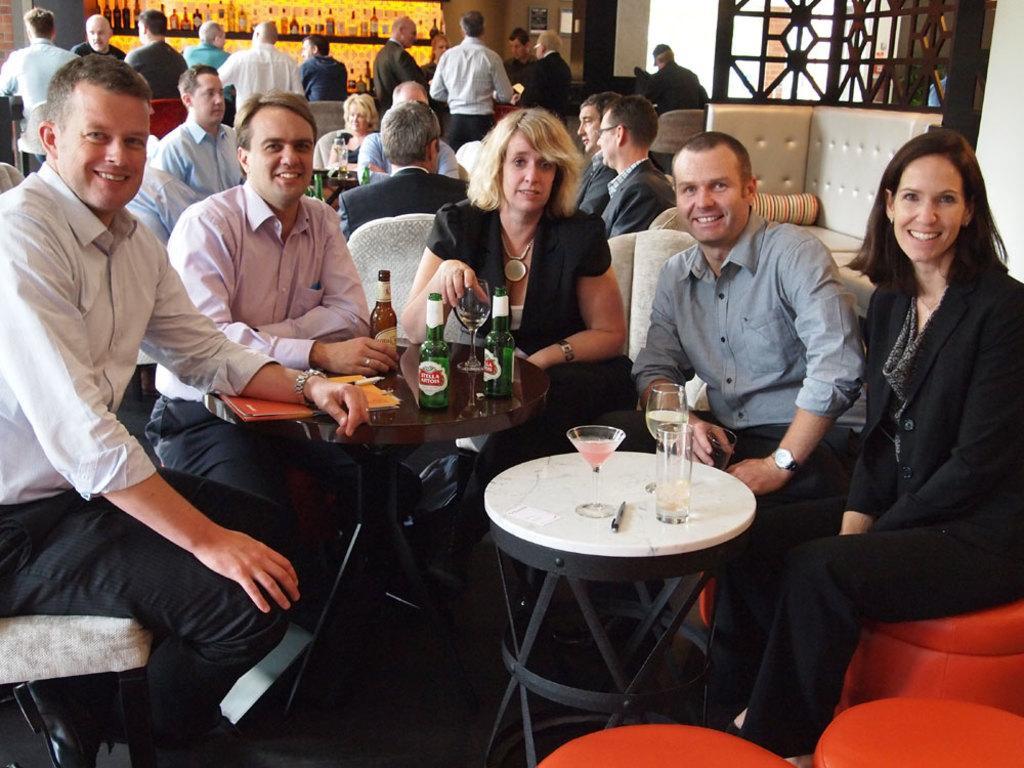Describe this image in one or two sentences. In this Image I see number of people in which most of them are sitting on chairs and rest of them standing over here. I see that these 4 people are smiling and there are bottles and glasses on these tables. In the background I see number of bottles over here. 